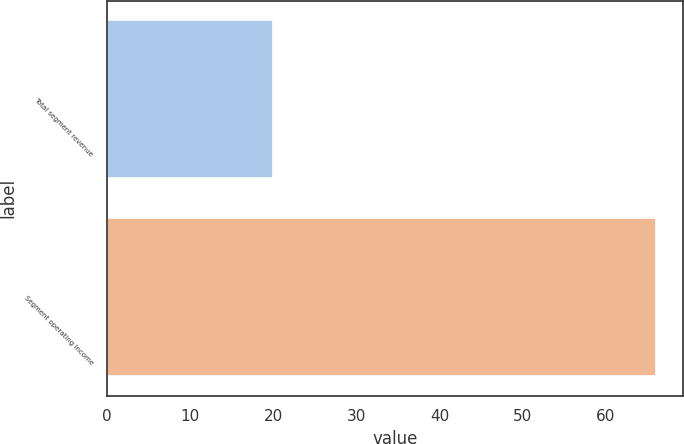Convert chart to OTSL. <chart><loc_0><loc_0><loc_500><loc_500><bar_chart><fcel>Total segment revenue<fcel>Segment operating income<nl><fcel>20<fcel>66<nl></chart> 